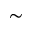Convert formula to latex. <formula><loc_0><loc_0><loc_500><loc_500>\sim</formula> 